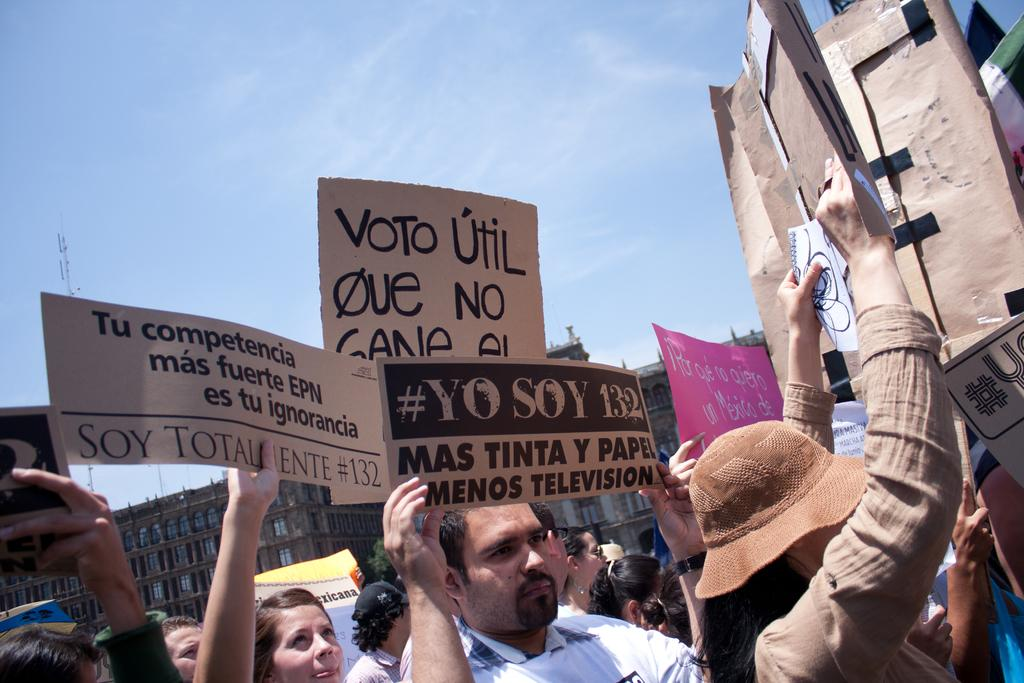How many people are present in the image? There are many people in the image. What are the people holding in the image? The people are holding placards. Where are the people located in the image? The people are on the road. What can be seen in the background of the image? There is a building in the background of the image. What is visible at the top of the image? The sky is visible at the top of the image. What type of jewel can be seen on the church in the image? There is no church or jewel present in the image. What title is given to the person holding the largest placard in the image? There is no title mentioned or implied for any person in the image. 